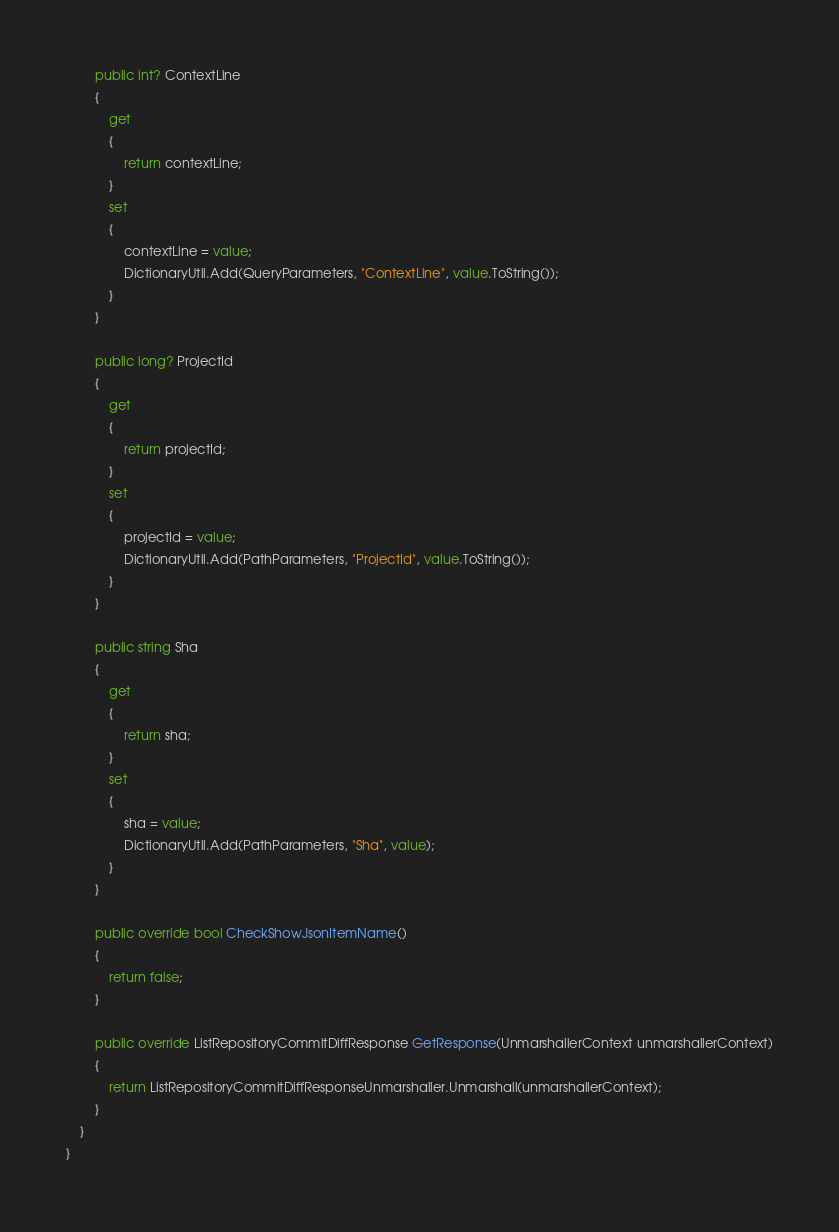Convert code to text. <code><loc_0><loc_0><loc_500><loc_500><_C#_>
		public int? ContextLine
		{
			get
			{
				return contextLine;
			}
			set	
			{
				contextLine = value;
				DictionaryUtil.Add(QueryParameters, "ContextLine", value.ToString());
			}
		}

		public long? ProjectId
		{
			get
			{
				return projectId;
			}
			set	
			{
				projectId = value;
				DictionaryUtil.Add(PathParameters, "ProjectId", value.ToString());
			}
		}

		public string Sha
		{
			get
			{
				return sha;
			}
			set	
			{
				sha = value;
				DictionaryUtil.Add(PathParameters, "Sha", value);
			}
		}

		public override bool CheckShowJsonItemName()
		{
			return false;
		}

        public override ListRepositoryCommitDiffResponse GetResponse(UnmarshallerContext unmarshallerContext)
        {
            return ListRepositoryCommitDiffResponseUnmarshaller.Unmarshall(unmarshallerContext);
        }
    }
}
</code> 